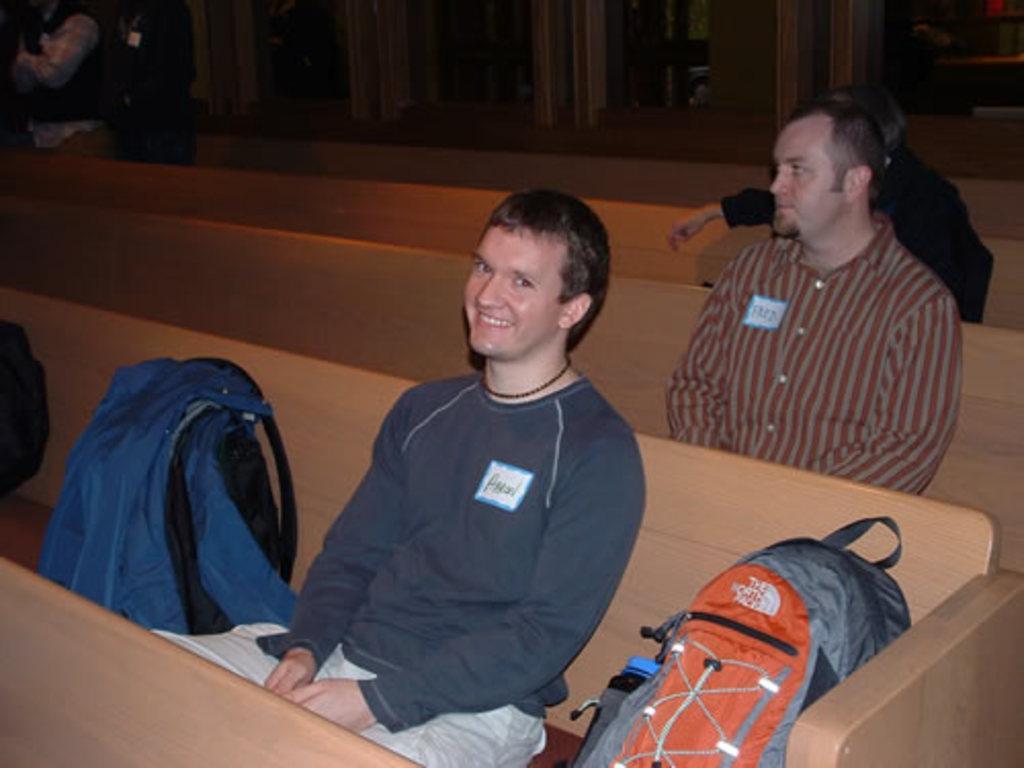Can you describe this image briefly? In this image I can see a wooden benches and in the first bench I can see a person sitting beside that person I can see luggage bags and the person is smiling and back side the person I can see another person sitting on the bench , in the top left I can see two persons standing , on the right side I can see a person wearing a black color t- shirt. 